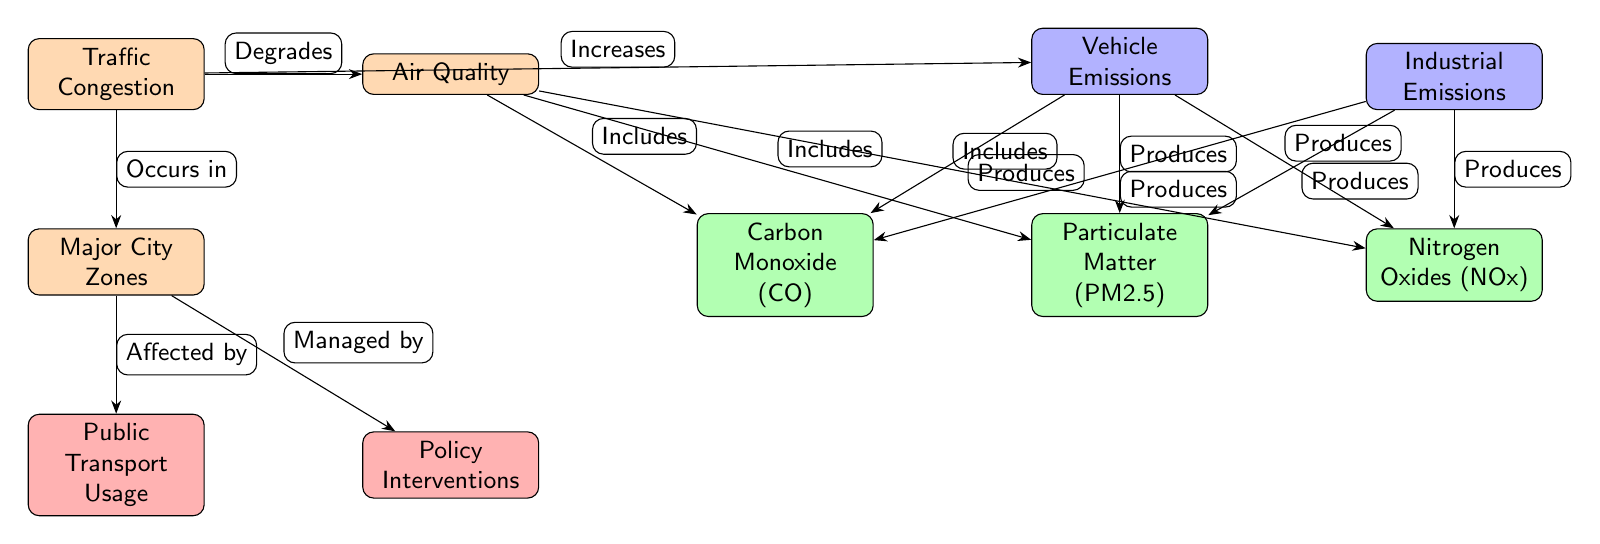What are the major pollutants listed in the diagram? The diagram clearly lists three major pollutants under the "Air Quality" node: Carbon Monoxide (CO), Particulate Matter (PM2.5), and Nitrogen Oxides (NOx). These are the pollutants specifically mentioned in relation to air quality.
Answer: Carbon Monoxide (CO), Particulate Matter (PM2.5), Nitrogen Oxides (NOx) How does traffic congestion affect air quality? The diagram shows that traffic congestion "degrades" air quality, indicating a negative impact. The arrows signify that there is a direct relationship where increased congestion leads to worse air quality.
Answer: Degrades What type of emissions produces particulate matter? Particulate Matter (PM2.5) is produced by both Vehicle Emissions and Industrial Emissions, as indicated by the arrows leading from these sources to the pollutant node.
Answer: Vehicle Emissions, Industrial Emissions Which node is directly affected by major city zones? The diagram illustrates that Public Transport Usage and Policy Interventions are both nodes that are "affected by" Major City Zones. This indicates that the conditions in those areas can influence these interventions.
Answer: Public Transport Usage, Policy Interventions What does the diagram suggest is a potential intervention for managing traffic congestion? The diagram lists two interventions that are related to major city zones: Public Transport Usage and Policy Interventions. This implies that these interventions can help alleviate issues stemming from traffic congestion.
Answer: Public Transport Usage, Policy Interventions How many pollutants are included in the air quality section? The air quality section includes a total of three specific pollutants: Carbon Monoxide (CO), Particulate Matter (PM2.5), and Nitrogen Oxides (NOx). Simply counting these pollutants gives the total number.
Answer: 3 What relationship exists between vehicle emissions and nitrogen oxides? The diagram indicates that Vehicle Emissions "produces" Nitrogen Oxides (NOx). This shows a direct causal relationship where vehicle emissions lead to the generation of NOx as a pollutant.
Answer: Produces How are vehicle emissions categorized in the diagram? Vehicle Emissions are categorized as a source of pollution that contributes to air quality degradation. The diagram clearly indicates this relationship with an arrow pointing from Vehicle Emissions toward the pollutant nodes.
Answer: Source Which element manages the impact of major city zones? The diagram shows that Policy Interventions are responsible for managing the effects stemming from Major City Zones. This management aspect is explicitly stated with the directional relationship.
Answer: Policy Interventions 